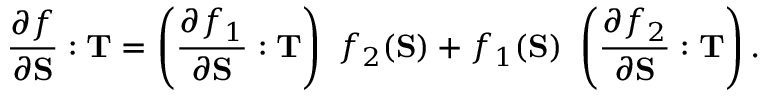<formula> <loc_0><loc_0><loc_500><loc_500>{ \frac { \partial f } { \partial S } } \colon T = \left ( { \frac { \partial f _ { 1 } } { \partial S } } \colon T \right ) f _ { 2 } ( S ) + f _ { 1 } ( S ) \left ( { \frac { \partial f _ { 2 } } { \partial S } } \colon T \right ) .</formula> 